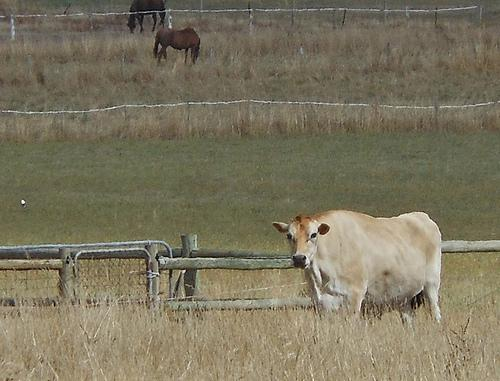What type of objects are the cow's eyes? The cow's eyes are black. How many total patches of short green grass are present in the field? There are 10 patches of short green grass in the field. Identify two animals present in the image with their colors. A large white and tan cow, and a small brown horse. Explain the cow's presence in relation to its surroundings. The cow is standing in the grass next to the fence behind it. What type of fence can be found in the image, and what material is it made of? A wooden fence with a metal gate, along with a small grey fence. How many horses are present in the image? There are two horses in the image. What are the overall emotions or sentiments evoked by this image? A serene, calm, and peaceful pastoral scene with animals grazing in a pasture. What is the color of the main cow in the image? The main cow is white and tan. Describe any small items, animals or plants present in the image. A little white bird, a small white poll, and a long white rope. What is the condition of the grass, and are there any notable qualities or colors? There are areas of short, green and yellow grass, and some tall, dark brown grass. A big red tractor is parked near the wooden fence. Notice its powerful engine. There is no mention of a tractor, especially a red one, in the image, nor is there any indication of the presence of a vehicle near the fence. A flock of seagulls is flying in the sky above the pasture. Aren't they beautiful? The image does not mention any seagulls or birds flying in the sky above the pasture, so this instruction is misleading. Watch out for the large, blue snake slithering through the dark brown grass! It must be hungry. There is no mention of a large blue snake in the image, nor is there any indication that an animal is slithering through the grass. You can see a family of rabbits playing in the short green grass in the field. It's a lovely sight. There is no mention of rabbits in the image or any indication of animals playing in the grass, making this instruction misleading. Can you find the pink elephant hiding behind the fence? It seems shy. There is no mention of a pink elephant in the image, nor any indication that any object or animal is hiding behind the fence. The golden retriever is happily wagging its tail by the small brown horse. Isn't that adorable? There is no mention of a golden retriever in the image or any indication of a dog interacting with a horse, making this instruction misleading. 